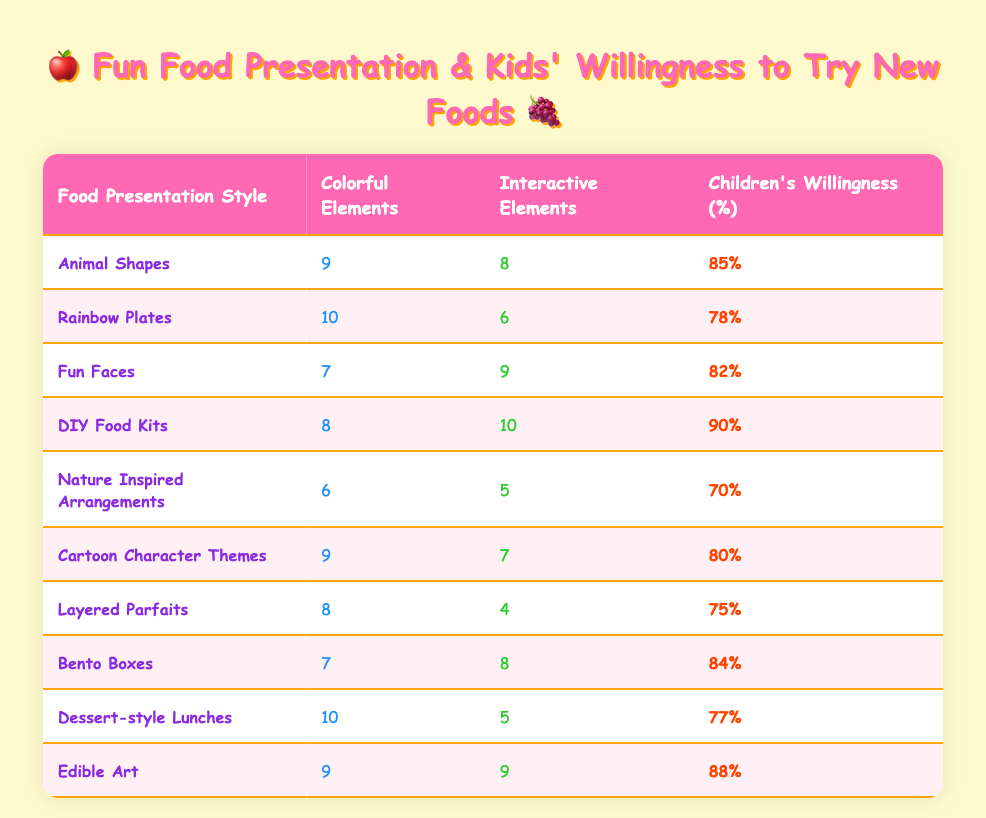What is the food presentation style with the highest children's willingness to try new foods? From the table, we can look for the highest percentage listed under "Children's Willingness (%)". The highest value is 90%, corresponding to the food presentation style "DIY Food Kits".
Answer: DIY Food Kits How many colorful elements are in "Rainbow Plates"? Looking at the row for "Rainbow Plates", the number under the "Colorful Elements" column is 10.
Answer: 10 What is the average children's willingness for food presentation styles with more than 7 colorful elements? We filter the rows where colorful elements are greater than 7: "Rainbow Plates" (78%), "Animal Shapes" (85%), "Cartoon Character Themes" (80%), "Edible Art" (88%). Adding these values gives us (78 + 85 + 80 + 88) = 331. There are 4 food presentation styles, so the average is 331/4 = 82.75.
Answer: 82.75 Does "Nature Inspired Arrangements" have more interactive elements than "Layered Parfaits"? Checking the rows for each style, "Nature Inspired Arrangements" has 5 interactive elements while "Layered Parfaits" has 4. Since 5 is greater than 4, the statement is true.
Answer: Yes What is the difference in children's willingness to try new foods between "DIY Food Kits" and "Nature Inspired Arrangements"? For each style, we find their willingness percentages: "DIY Food Kits" = 90% and "Nature Inspired Arrangements" = 70%. The difference is 90 - 70 = 20.
Answer: 20 